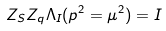Convert formula to latex. <formula><loc_0><loc_0><loc_500><loc_500>Z _ { S } Z _ { q } \Lambda _ { I } ( p ^ { 2 } = \mu ^ { 2 } ) = I</formula> 